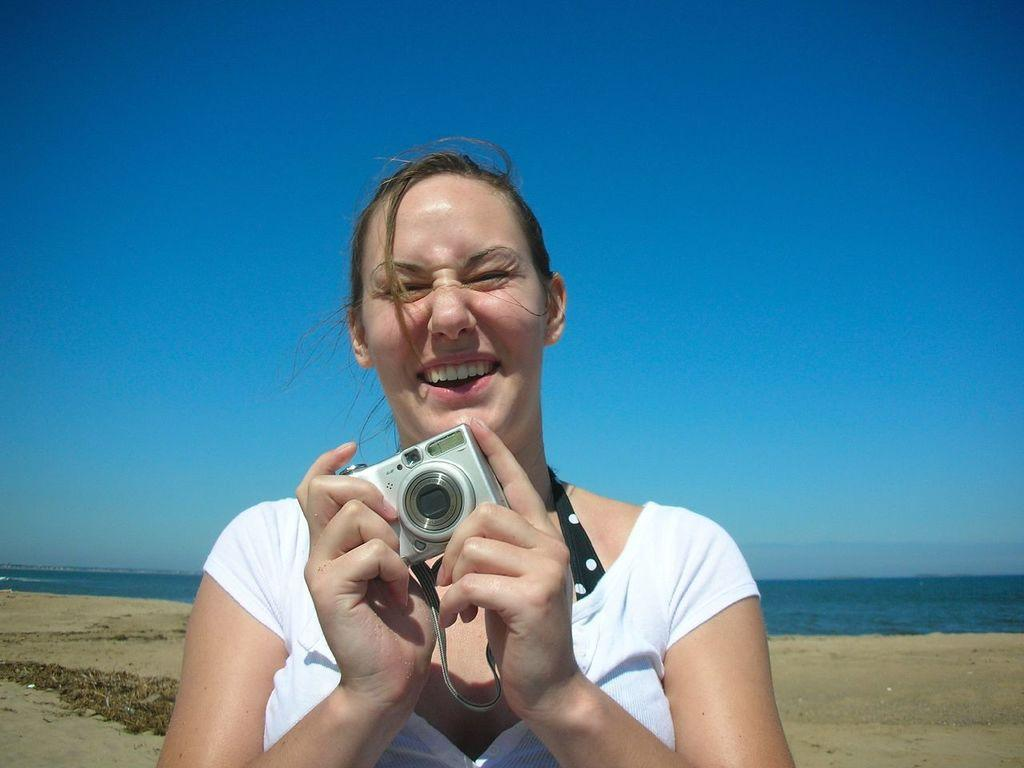Who is in the image? There is a woman in the image. What is the woman holding? The woman is holding a camera. What expression does the woman have? The woman is smiling. What can be seen in the background of the image? There is sand, water, and the sky visible in the background of the image. What type of dust can be seen on the tub in the image? There is no tub or dust present in the image. How does the woman control the camera in the image? The image does not show the woman controlling the camera, only holding it. 